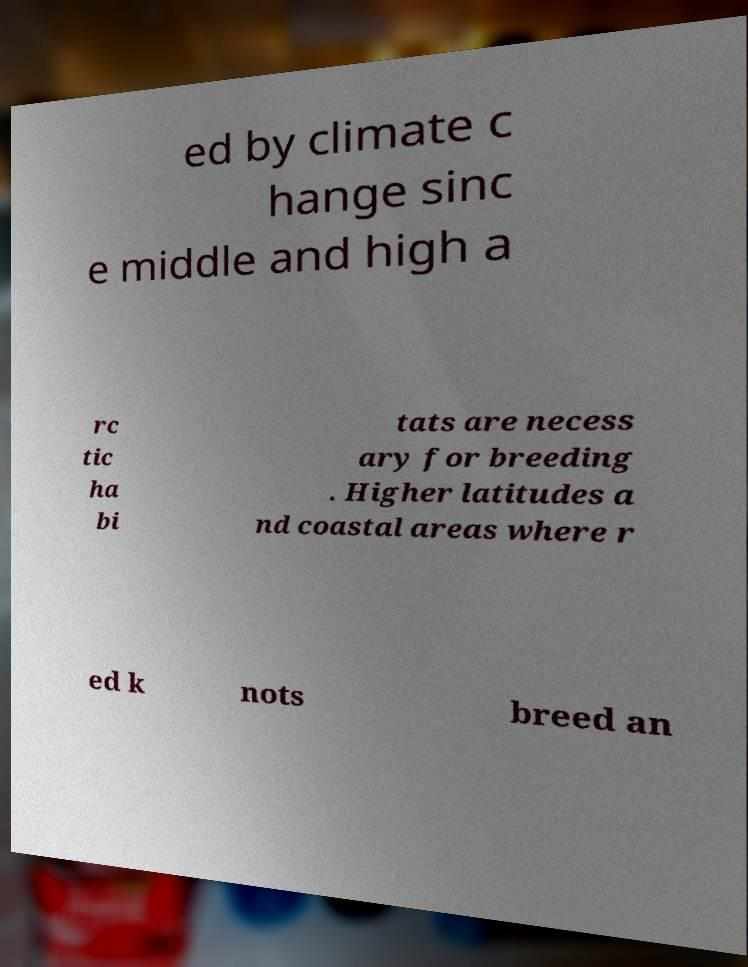Can you accurately transcribe the text from the provided image for me? ed by climate c hange sinc e middle and high a rc tic ha bi tats are necess ary for breeding . Higher latitudes a nd coastal areas where r ed k nots breed an 